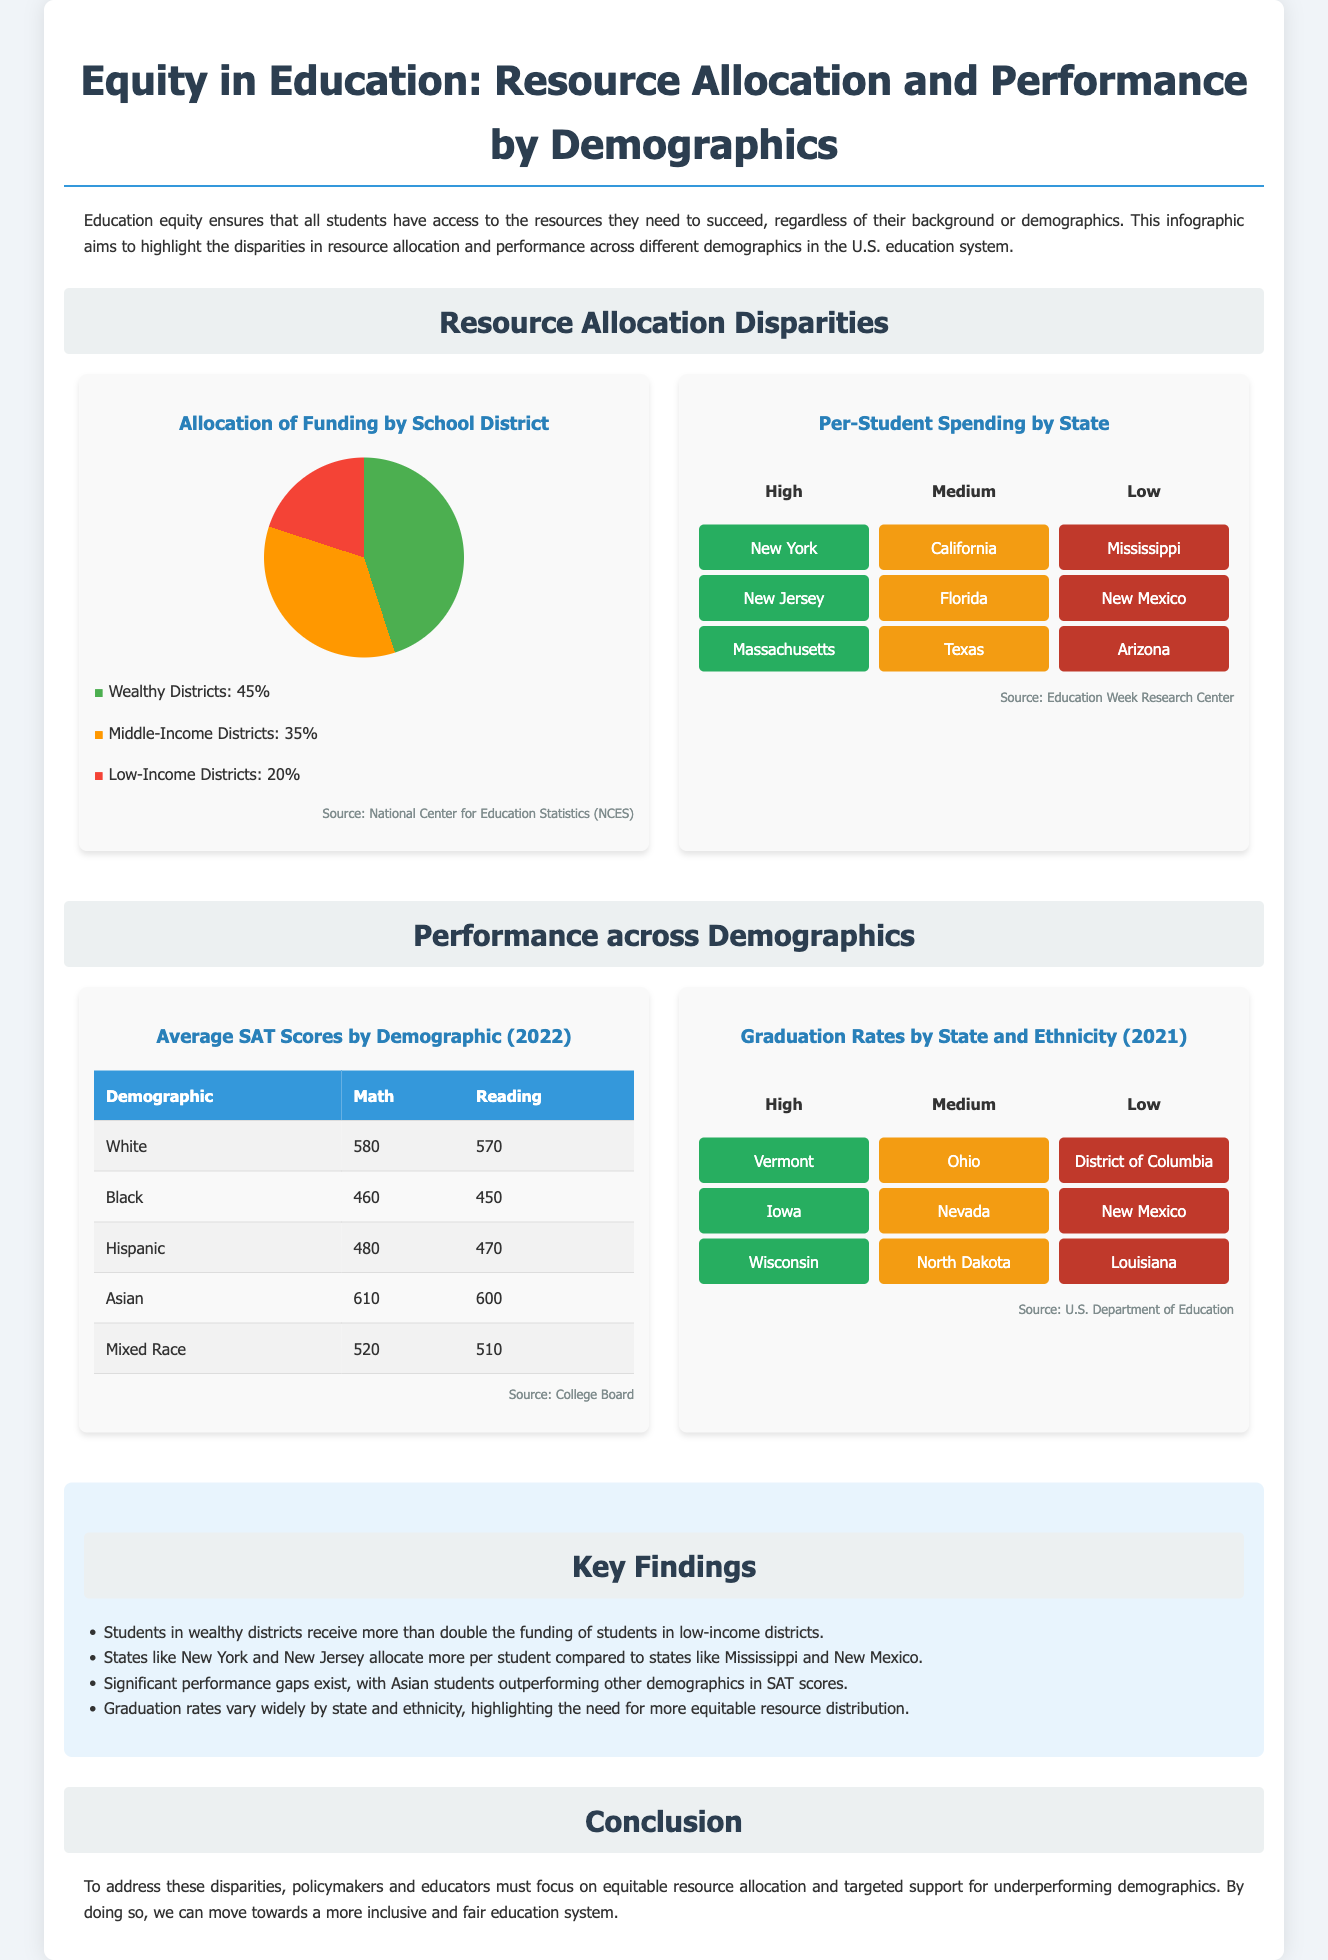What percentage of funding goes to wealthy districts? The document states that wealthy districts receive 45% of the funding.
Answer: 45% Which state has the highest per-student spending? The heat map indicates that New York is among the states with high per-student spending.
Answer: New York What is the average SAT score in Math for Hispanic students? The average SAT score in Math for Hispanic students is shown as 480.
Answer: 480 Which demographic has the lowest average Reading SAT score? According to the table, Black students have the lowest average Reading SAT score at 450.
Answer: Black What percentage of funding is allocated to low-income districts? The infographic indicates that low-income districts receive 20% of the funding.
Answer: 20% Which state has the lowest graduation rates according to the heat map? The low graduation rate states mentioned include the District of Columbia as the lowest.
Answer: District of Columbia How much more funding do wealthy districts receive compared to low-income districts? Wealthy districts receive more than double the funding compared to low-income districts, as noted in the key findings.
Answer: More than double What is the conclusion about resource allocation? The conclusion states that there should be a focus on equitable resource allocation to address disparities.
Answer: Equitable resource allocation Which ethnicity outperforms others in SAT scores? The document highlights that Asian students outperform other demographics in SAT scores.
Answer: Asian students 